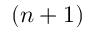Convert formula to latex. <formula><loc_0><loc_0><loc_500><loc_500>( n + 1 )</formula> 